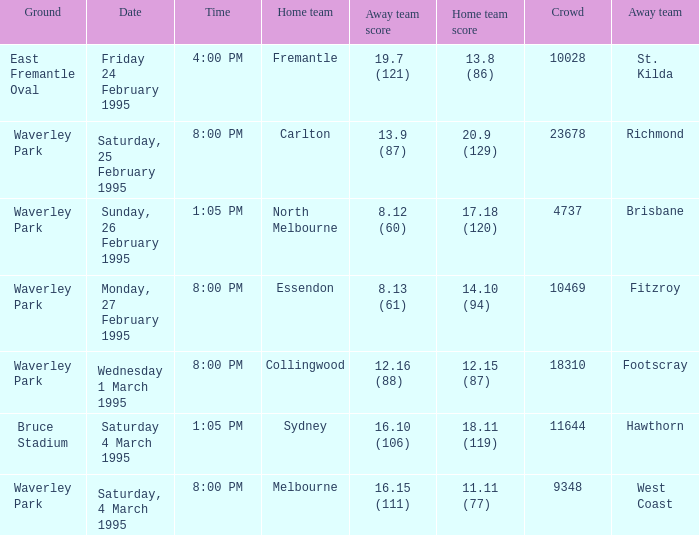Name the ground for essendon Waverley Park. 